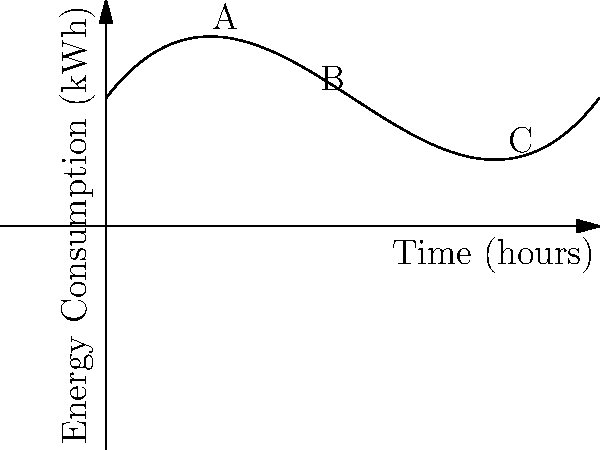The graph shows the energy consumption of a smart building over a 10-hour period. The consumption is modeled by the polynomial function $f(x) = 0.1x^3 - 1.5x^2 + 5x + 10$, where $x$ is time in hours and $f(x)$ is energy consumption in kWh. At which point (A, B, or C) does the building's energy consumption rate (kWh/hour) start increasing again after a period of decrease? To determine where the energy consumption rate starts increasing again, we need to analyze the derivative of the function. The steps are as follows:

1) The derivative of $f(x) = 0.1x^3 - 1.5x^2 + 5x + 10$ is:
   $f'(x) = 0.3x^2 - 3x + 5$

2) The derivative represents the rate of change of energy consumption. When $f'(x)$ is positive, energy consumption is increasing; when negative, it's decreasing.

3) To find where the rate changes from decreasing to increasing, we need to find the minimum point of $f'(x)$. This occurs where $f''(x) = 0$.

4) The second derivative is:
   $f''(x) = 0.6x - 3$

5) Setting $f''(x) = 0$:
   $0.6x - 3 = 0$
   $0.6x = 3$
   $x = 5$

6) This means the energy consumption rate is at its minimum when $x = 5$, which corresponds to point B on the graph.

7) After this point (to the right of B), the rate starts increasing again.

Therefore, point B (at x = 5 hours) is where the energy consumption rate starts increasing again after a period of decrease.
Answer: B 